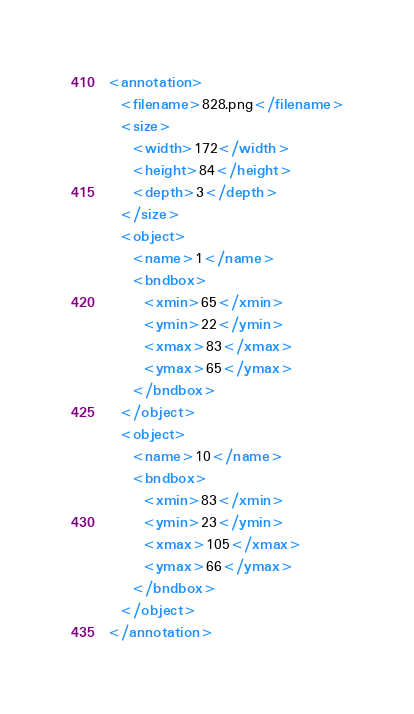<code> <loc_0><loc_0><loc_500><loc_500><_XML_><annotation>
  <filename>828.png</filename>
  <size>
    <width>172</width>
    <height>84</height>
    <depth>3</depth>
  </size>
  <object>
    <name>1</name>
    <bndbox>
      <xmin>65</xmin>
      <ymin>22</ymin>
      <xmax>83</xmax>
      <ymax>65</ymax>
    </bndbox>
  </object>
  <object>
    <name>10</name>
    <bndbox>
      <xmin>83</xmin>
      <ymin>23</ymin>
      <xmax>105</xmax>
      <ymax>66</ymax>
    </bndbox>
  </object>
</annotation>
</code> 